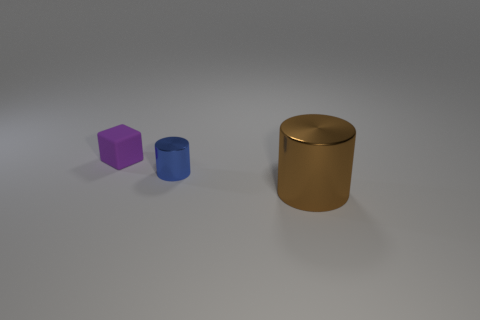Add 2 large purple matte things. How many objects exist? 5 Subtract all cylinders. How many objects are left? 1 Subtract all red matte things. Subtract all brown shiny things. How many objects are left? 2 Add 3 purple rubber cubes. How many purple rubber cubes are left? 4 Add 3 brown cylinders. How many brown cylinders exist? 4 Subtract 0 green blocks. How many objects are left? 3 